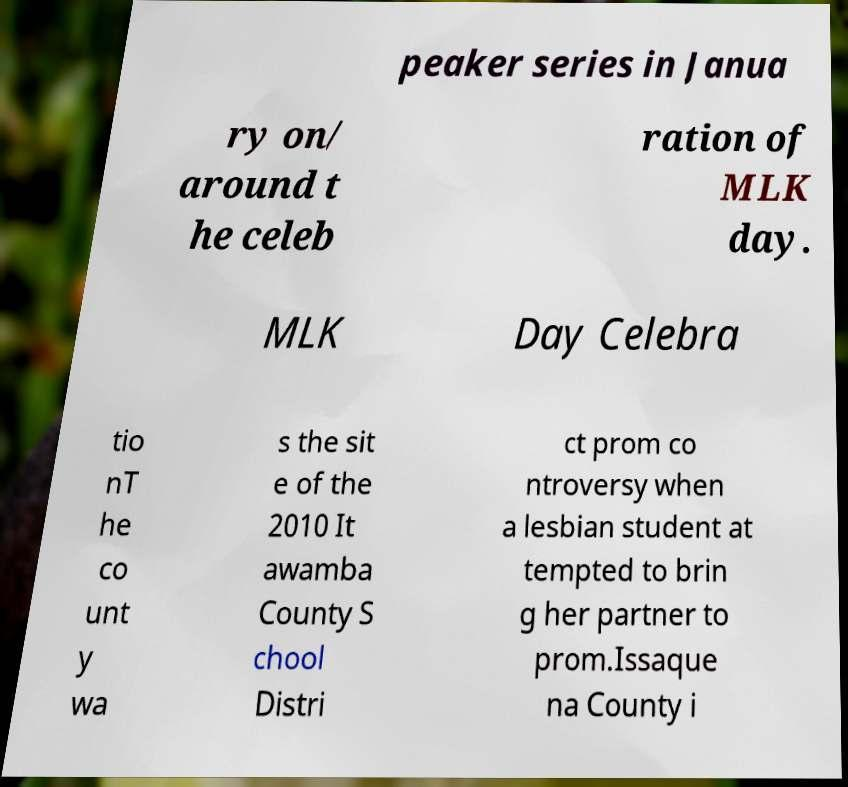Please identify and transcribe the text found in this image. peaker series in Janua ry on/ around t he celeb ration of MLK day. MLK Day Celebra tio nT he co unt y wa s the sit e of the 2010 It awamba County S chool Distri ct prom co ntroversy when a lesbian student at tempted to brin g her partner to prom.Issaque na County i 